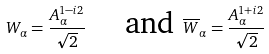Convert formula to latex. <formula><loc_0><loc_0><loc_500><loc_500>W _ { \alpha } = \frac { A _ { \alpha } ^ { 1 - i 2 } } { \sqrt { 2 } } \text { \quad and } \overline { W } _ { \alpha } = \frac { A _ { \alpha } ^ { 1 + i 2 } } { \sqrt { 2 } }</formula> 